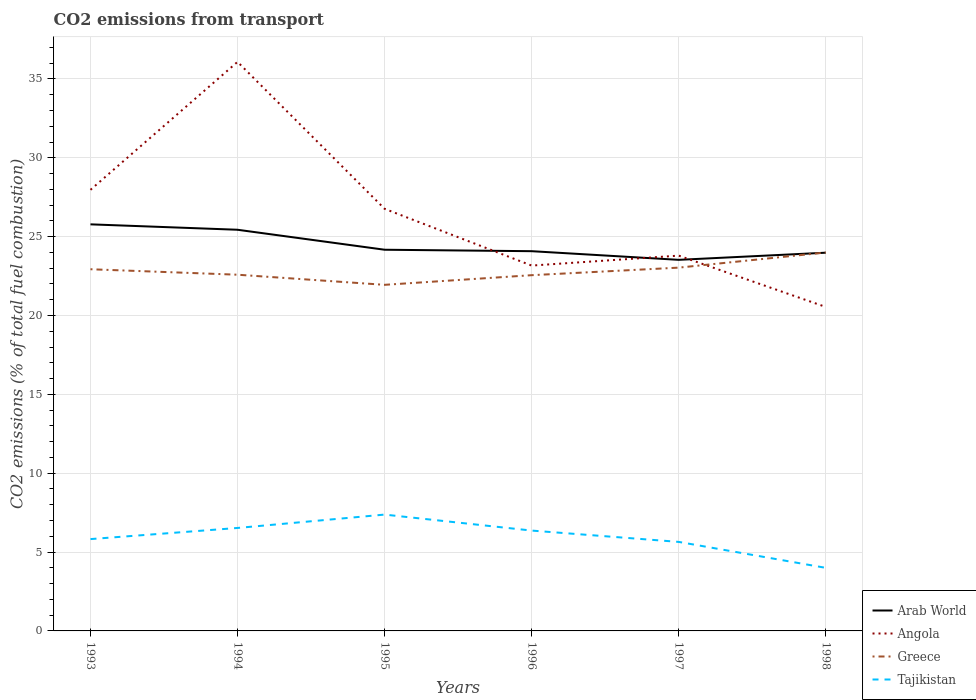How many different coloured lines are there?
Your answer should be compact. 4. Across all years, what is the maximum total CO2 emitted in Arab World?
Your response must be concise. 23.53. What is the total total CO2 emitted in Angola in the graph?
Make the answer very short. 3.6. What is the difference between the highest and the second highest total CO2 emitted in Greece?
Offer a very short reply. 2.05. Is the total CO2 emitted in Greece strictly greater than the total CO2 emitted in Angola over the years?
Your answer should be compact. No. How many years are there in the graph?
Your answer should be very brief. 6. Does the graph contain any zero values?
Your response must be concise. No. How many legend labels are there?
Provide a short and direct response. 4. What is the title of the graph?
Keep it short and to the point. CO2 emissions from transport. Does "St. Kitts and Nevis" appear as one of the legend labels in the graph?
Keep it short and to the point. No. What is the label or title of the Y-axis?
Your answer should be very brief. CO2 emissions (% of total fuel combustion). What is the CO2 emissions (% of total fuel combustion) in Arab World in 1993?
Your response must be concise. 25.78. What is the CO2 emissions (% of total fuel combustion) of Angola in 1993?
Your answer should be compact. 27.97. What is the CO2 emissions (% of total fuel combustion) of Greece in 1993?
Your response must be concise. 22.94. What is the CO2 emissions (% of total fuel combustion) in Tajikistan in 1993?
Your response must be concise. 5.82. What is the CO2 emissions (% of total fuel combustion) of Arab World in 1994?
Provide a short and direct response. 25.44. What is the CO2 emissions (% of total fuel combustion) in Angola in 1994?
Keep it short and to the point. 36.08. What is the CO2 emissions (% of total fuel combustion) in Greece in 1994?
Your answer should be very brief. 22.59. What is the CO2 emissions (% of total fuel combustion) in Tajikistan in 1994?
Offer a very short reply. 6.53. What is the CO2 emissions (% of total fuel combustion) of Arab World in 1995?
Offer a very short reply. 24.17. What is the CO2 emissions (% of total fuel combustion) of Angola in 1995?
Your response must be concise. 26.77. What is the CO2 emissions (% of total fuel combustion) in Greece in 1995?
Offer a very short reply. 21.95. What is the CO2 emissions (% of total fuel combustion) of Tajikistan in 1995?
Your answer should be very brief. 7.38. What is the CO2 emissions (% of total fuel combustion) of Arab World in 1996?
Provide a short and direct response. 24.08. What is the CO2 emissions (% of total fuel combustion) in Angola in 1996?
Offer a very short reply. 23.17. What is the CO2 emissions (% of total fuel combustion) in Greece in 1996?
Your answer should be compact. 22.56. What is the CO2 emissions (% of total fuel combustion) in Tajikistan in 1996?
Keep it short and to the point. 6.36. What is the CO2 emissions (% of total fuel combustion) of Arab World in 1997?
Your answer should be compact. 23.53. What is the CO2 emissions (% of total fuel combustion) of Angola in 1997?
Keep it short and to the point. 23.8. What is the CO2 emissions (% of total fuel combustion) in Greece in 1997?
Ensure brevity in your answer.  23.04. What is the CO2 emissions (% of total fuel combustion) of Tajikistan in 1997?
Provide a short and direct response. 5.65. What is the CO2 emissions (% of total fuel combustion) in Arab World in 1998?
Provide a short and direct response. 23.98. What is the CO2 emissions (% of total fuel combustion) in Angola in 1998?
Make the answer very short. 20.54. What is the CO2 emissions (% of total fuel combustion) in Greece in 1998?
Offer a very short reply. 24. What is the CO2 emissions (% of total fuel combustion) of Tajikistan in 1998?
Give a very brief answer. 4. Across all years, what is the maximum CO2 emissions (% of total fuel combustion) in Arab World?
Give a very brief answer. 25.78. Across all years, what is the maximum CO2 emissions (% of total fuel combustion) in Angola?
Make the answer very short. 36.08. Across all years, what is the maximum CO2 emissions (% of total fuel combustion) of Greece?
Keep it short and to the point. 24. Across all years, what is the maximum CO2 emissions (% of total fuel combustion) of Tajikistan?
Keep it short and to the point. 7.38. Across all years, what is the minimum CO2 emissions (% of total fuel combustion) of Arab World?
Offer a very short reply. 23.53. Across all years, what is the minimum CO2 emissions (% of total fuel combustion) of Angola?
Your answer should be compact. 20.54. Across all years, what is the minimum CO2 emissions (% of total fuel combustion) in Greece?
Your answer should be very brief. 21.95. Across all years, what is the minimum CO2 emissions (% of total fuel combustion) in Tajikistan?
Ensure brevity in your answer.  4. What is the total CO2 emissions (% of total fuel combustion) in Arab World in the graph?
Provide a succinct answer. 146.99. What is the total CO2 emissions (% of total fuel combustion) of Angola in the graph?
Offer a terse response. 158.34. What is the total CO2 emissions (% of total fuel combustion) in Greece in the graph?
Keep it short and to the point. 137.06. What is the total CO2 emissions (% of total fuel combustion) of Tajikistan in the graph?
Give a very brief answer. 35.74. What is the difference between the CO2 emissions (% of total fuel combustion) of Arab World in 1993 and that in 1994?
Your answer should be compact. 0.34. What is the difference between the CO2 emissions (% of total fuel combustion) in Angola in 1993 and that in 1994?
Your response must be concise. -8.11. What is the difference between the CO2 emissions (% of total fuel combustion) in Greece in 1993 and that in 1994?
Your answer should be compact. 0.35. What is the difference between the CO2 emissions (% of total fuel combustion) of Tajikistan in 1993 and that in 1994?
Your answer should be compact. -0.71. What is the difference between the CO2 emissions (% of total fuel combustion) of Arab World in 1993 and that in 1995?
Offer a very short reply. 1.61. What is the difference between the CO2 emissions (% of total fuel combustion) of Angola in 1993 and that in 1995?
Offer a very short reply. 1.2. What is the difference between the CO2 emissions (% of total fuel combustion) of Tajikistan in 1993 and that in 1995?
Your answer should be very brief. -1.55. What is the difference between the CO2 emissions (% of total fuel combustion) of Arab World in 1993 and that in 1996?
Offer a very short reply. 1.7. What is the difference between the CO2 emissions (% of total fuel combustion) in Angola in 1993 and that in 1996?
Offer a terse response. 4.8. What is the difference between the CO2 emissions (% of total fuel combustion) of Greece in 1993 and that in 1996?
Your answer should be very brief. 0.38. What is the difference between the CO2 emissions (% of total fuel combustion) in Tajikistan in 1993 and that in 1996?
Make the answer very short. -0.54. What is the difference between the CO2 emissions (% of total fuel combustion) in Arab World in 1993 and that in 1997?
Your answer should be compact. 2.25. What is the difference between the CO2 emissions (% of total fuel combustion) of Angola in 1993 and that in 1997?
Your answer should be very brief. 4.17. What is the difference between the CO2 emissions (% of total fuel combustion) in Greece in 1993 and that in 1997?
Provide a short and direct response. -0.1. What is the difference between the CO2 emissions (% of total fuel combustion) of Tajikistan in 1993 and that in 1997?
Make the answer very short. 0.18. What is the difference between the CO2 emissions (% of total fuel combustion) of Arab World in 1993 and that in 1998?
Provide a succinct answer. 1.8. What is the difference between the CO2 emissions (% of total fuel combustion) in Angola in 1993 and that in 1998?
Keep it short and to the point. 7.43. What is the difference between the CO2 emissions (% of total fuel combustion) in Greece in 1993 and that in 1998?
Your answer should be very brief. -1.06. What is the difference between the CO2 emissions (% of total fuel combustion) of Tajikistan in 1993 and that in 1998?
Provide a succinct answer. 1.82. What is the difference between the CO2 emissions (% of total fuel combustion) of Arab World in 1994 and that in 1995?
Your answer should be very brief. 1.27. What is the difference between the CO2 emissions (% of total fuel combustion) of Angola in 1994 and that in 1995?
Ensure brevity in your answer.  9.32. What is the difference between the CO2 emissions (% of total fuel combustion) in Greece in 1994 and that in 1995?
Keep it short and to the point. 0.64. What is the difference between the CO2 emissions (% of total fuel combustion) in Tajikistan in 1994 and that in 1995?
Keep it short and to the point. -0.85. What is the difference between the CO2 emissions (% of total fuel combustion) in Arab World in 1994 and that in 1996?
Offer a very short reply. 1.36. What is the difference between the CO2 emissions (% of total fuel combustion) of Angola in 1994 and that in 1996?
Keep it short and to the point. 12.92. What is the difference between the CO2 emissions (% of total fuel combustion) of Greece in 1994 and that in 1996?
Make the answer very short. 0.03. What is the difference between the CO2 emissions (% of total fuel combustion) in Tajikistan in 1994 and that in 1996?
Provide a short and direct response. 0.17. What is the difference between the CO2 emissions (% of total fuel combustion) of Arab World in 1994 and that in 1997?
Your response must be concise. 1.91. What is the difference between the CO2 emissions (% of total fuel combustion) in Angola in 1994 and that in 1997?
Offer a terse response. 12.29. What is the difference between the CO2 emissions (% of total fuel combustion) in Greece in 1994 and that in 1997?
Provide a succinct answer. -0.45. What is the difference between the CO2 emissions (% of total fuel combustion) of Tajikistan in 1994 and that in 1997?
Your response must be concise. 0.88. What is the difference between the CO2 emissions (% of total fuel combustion) of Arab World in 1994 and that in 1998?
Offer a very short reply. 1.46. What is the difference between the CO2 emissions (% of total fuel combustion) of Angola in 1994 and that in 1998?
Make the answer very short. 15.54. What is the difference between the CO2 emissions (% of total fuel combustion) in Greece in 1994 and that in 1998?
Give a very brief answer. -1.41. What is the difference between the CO2 emissions (% of total fuel combustion) in Tajikistan in 1994 and that in 1998?
Your response must be concise. 2.53. What is the difference between the CO2 emissions (% of total fuel combustion) in Arab World in 1995 and that in 1996?
Offer a terse response. 0.09. What is the difference between the CO2 emissions (% of total fuel combustion) of Angola in 1995 and that in 1996?
Offer a terse response. 3.6. What is the difference between the CO2 emissions (% of total fuel combustion) in Greece in 1995 and that in 1996?
Your answer should be compact. -0.61. What is the difference between the CO2 emissions (% of total fuel combustion) in Tajikistan in 1995 and that in 1996?
Your answer should be compact. 1.01. What is the difference between the CO2 emissions (% of total fuel combustion) in Arab World in 1995 and that in 1997?
Give a very brief answer. 0.64. What is the difference between the CO2 emissions (% of total fuel combustion) in Angola in 1995 and that in 1997?
Your answer should be very brief. 2.97. What is the difference between the CO2 emissions (% of total fuel combustion) in Greece in 1995 and that in 1997?
Your answer should be compact. -1.09. What is the difference between the CO2 emissions (% of total fuel combustion) of Tajikistan in 1995 and that in 1997?
Make the answer very short. 1.73. What is the difference between the CO2 emissions (% of total fuel combustion) of Arab World in 1995 and that in 1998?
Your answer should be very brief. 0.19. What is the difference between the CO2 emissions (% of total fuel combustion) of Angola in 1995 and that in 1998?
Provide a succinct answer. 6.22. What is the difference between the CO2 emissions (% of total fuel combustion) in Greece in 1995 and that in 1998?
Ensure brevity in your answer.  -2.05. What is the difference between the CO2 emissions (% of total fuel combustion) in Tajikistan in 1995 and that in 1998?
Make the answer very short. 3.38. What is the difference between the CO2 emissions (% of total fuel combustion) in Arab World in 1996 and that in 1997?
Give a very brief answer. 0.55. What is the difference between the CO2 emissions (% of total fuel combustion) in Angola in 1996 and that in 1997?
Offer a terse response. -0.63. What is the difference between the CO2 emissions (% of total fuel combustion) in Greece in 1996 and that in 1997?
Offer a very short reply. -0.48. What is the difference between the CO2 emissions (% of total fuel combustion) of Tajikistan in 1996 and that in 1997?
Provide a short and direct response. 0.72. What is the difference between the CO2 emissions (% of total fuel combustion) of Arab World in 1996 and that in 1998?
Provide a succinct answer. 0.1. What is the difference between the CO2 emissions (% of total fuel combustion) in Angola in 1996 and that in 1998?
Your answer should be compact. 2.62. What is the difference between the CO2 emissions (% of total fuel combustion) in Greece in 1996 and that in 1998?
Your response must be concise. -1.44. What is the difference between the CO2 emissions (% of total fuel combustion) of Tajikistan in 1996 and that in 1998?
Provide a succinct answer. 2.36. What is the difference between the CO2 emissions (% of total fuel combustion) in Arab World in 1997 and that in 1998?
Offer a terse response. -0.45. What is the difference between the CO2 emissions (% of total fuel combustion) in Angola in 1997 and that in 1998?
Ensure brevity in your answer.  3.25. What is the difference between the CO2 emissions (% of total fuel combustion) in Greece in 1997 and that in 1998?
Your answer should be compact. -0.96. What is the difference between the CO2 emissions (% of total fuel combustion) of Tajikistan in 1997 and that in 1998?
Ensure brevity in your answer.  1.65. What is the difference between the CO2 emissions (% of total fuel combustion) in Arab World in 1993 and the CO2 emissions (% of total fuel combustion) in Angola in 1994?
Your answer should be compact. -10.3. What is the difference between the CO2 emissions (% of total fuel combustion) of Arab World in 1993 and the CO2 emissions (% of total fuel combustion) of Greece in 1994?
Offer a very short reply. 3.19. What is the difference between the CO2 emissions (% of total fuel combustion) in Arab World in 1993 and the CO2 emissions (% of total fuel combustion) in Tajikistan in 1994?
Provide a succinct answer. 19.25. What is the difference between the CO2 emissions (% of total fuel combustion) of Angola in 1993 and the CO2 emissions (% of total fuel combustion) of Greece in 1994?
Make the answer very short. 5.38. What is the difference between the CO2 emissions (% of total fuel combustion) in Angola in 1993 and the CO2 emissions (% of total fuel combustion) in Tajikistan in 1994?
Offer a terse response. 21.44. What is the difference between the CO2 emissions (% of total fuel combustion) in Greece in 1993 and the CO2 emissions (% of total fuel combustion) in Tajikistan in 1994?
Your response must be concise. 16.41. What is the difference between the CO2 emissions (% of total fuel combustion) in Arab World in 1993 and the CO2 emissions (% of total fuel combustion) in Angola in 1995?
Your response must be concise. -0.99. What is the difference between the CO2 emissions (% of total fuel combustion) in Arab World in 1993 and the CO2 emissions (% of total fuel combustion) in Greece in 1995?
Provide a short and direct response. 3.84. What is the difference between the CO2 emissions (% of total fuel combustion) of Arab World in 1993 and the CO2 emissions (% of total fuel combustion) of Tajikistan in 1995?
Give a very brief answer. 18.41. What is the difference between the CO2 emissions (% of total fuel combustion) in Angola in 1993 and the CO2 emissions (% of total fuel combustion) in Greece in 1995?
Offer a very short reply. 6.03. What is the difference between the CO2 emissions (% of total fuel combustion) in Angola in 1993 and the CO2 emissions (% of total fuel combustion) in Tajikistan in 1995?
Provide a succinct answer. 20.59. What is the difference between the CO2 emissions (% of total fuel combustion) of Greece in 1993 and the CO2 emissions (% of total fuel combustion) of Tajikistan in 1995?
Make the answer very short. 15.56. What is the difference between the CO2 emissions (% of total fuel combustion) of Arab World in 1993 and the CO2 emissions (% of total fuel combustion) of Angola in 1996?
Provide a short and direct response. 2.61. What is the difference between the CO2 emissions (% of total fuel combustion) of Arab World in 1993 and the CO2 emissions (% of total fuel combustion) of Greece in 1996?
Your answer should be compact. 3.22. What is the difference between the CO2 emissions (% of total fuel combustion) of Arab World in 1993 and the CO2 emissions (% of total fuel combustion) of Tajikistan in 1996?
Your response must be concise. 19.42. What is the difference between the CO2 emissions (% of total fuel combustion) in Angola in 1993 and the CO2 emissions (% of total fuel combustion) in Greece in 1996?
Your answer should be compact. 5.41. What is the difference between the CO2 emissions (% of total fuel combustion) in Angola in 1993 and the CO2 emissions (% of total fuel combustion) in Tajikistan in 1996?
Your response must be concise. 21.61. What is the difference between the CO2 emissions (% of total fuel combustion) of Greece in 1993 and the CO2 emissions (% of total fuel combustion) of Tajikistan in 1996?
Provide a succinct answer. 16.57. What is the difference between the CO2 emissions (% of total fuel combustion) in Arab World in 1993 and the CO2 emissions (% of total fuel combustion) in Angola in 1997?
Provide a short and direct response. 1.98. What is the difference between the CO2 emissions (% of total fuel combustion) in Arab World in 1993 and the CO2 emissions (% of total fuel combustion) in Greece in 1997?
Your response must be concise. 2.75. What is the difference between the CO2 emissions (% of total fuel combustion) of Arab World in 1993 and the CO2 emissions (% of total fuel combustion) of Tajikistan in 1997?
Your response must be concise. 20.14. What is the difference between the CO2 emissions (% of total fuel combustion) of Angola in 1993 and the CO2 emissions (% of total fuel combustion) of Greece in 1997?
Ensure brevity in your answer.  4.94. What is the difference between the CO2 emissions (% of total fuel combustion) of Angola in 1993 and the CO2 emissions (% of total fuel combustion) of Tajikistan in 1997?
Offer a very short reply. 22.33. What is the difference between the CO2 emissions (% of total fuel combustion) of Greece in 1993 and the CO2 emissions (% of total fuel combustion) of Tajikistan in 1997?
Your answer should be very brief. 17.29. What is the difference between the CO2 emissions (% of total fuel combustion) of Arab World in 1993 and the CO2 emissions (% of total fuel combustion) of Angola in 1998?
Your answer should be very brief. 5.24. What is the difference between the CO2 emissions (% of total fuel combustion) of Arab World in 1993 and the CO2 emissions (% of total fuel combustion) of Greece in 1998?
Keep it short and to the point. 1.78. What is the difference between the CO2 emissions (% of total fuel combustion) of Arab World in 1993 and the CO2 emissions (% of total fuel combustion) of Tajikistan in 1998?
Give a very brief answer. 21.78. What is the difference between the CO2 emissions (% of total fuel combustion) of Angola in 1993 and the CO2 emissions (% of total fuel combustion) of Greece in 1998?
Provide a succinct answer. 3.97. What is the difference between the CO2 emissions (% of total fuel combustion) of Angola in 1993 and the CO2 emissions (% of total fuel combustion) of Tajikistan in 1998?
Keep it short and to the point. 23.97. What is the difference between the CO2 emissions (% of total fuel combustion) in Greece in 1993 and the CO2 emissions (% of total fuel combustion) in Tajikistan in 1998?
Give a very brief answer. 18.94. What is the difference between the CO2 emissions (% of total fuel combustion) in Arab World in 1994 and the CO2 emissions (% of total fuel combustion) in Angola in 1995?
Offer a terse response. -1.33. What is the difference between the CO2 emissions (% of total fuel combustion) in Arab World in 1994 and the CO2 emissions (% of total fuel combustion) in Greece in 1995?
Provide a succinct answer. 3.49. What is the difference between the CO2 emissions (% of total fuel combustion) of Arab World in 1994 and the CO2 emissions (% of total fuel combustion) of Tajikistan in 1995?
Offer a terse response. 18.06. What is the difference between the CO2 emissions (% of total fuel combustion) in Angola in 1994 and the CO2 emissions (% of total fuel combustion) in Greece in 1995?
Keep it short and to the point. 14.14. What is the difference between the CO2 emissions (% of total fuel combustion) in Angola in 1994 and the CO2 emissions (% of total fuel combustion) in Tajikistan in 1995?
Give a very brief answer. 28.71. What is the difference between the CO2 emissions (% of total fuel combustion) in Greece in 1994 and the CO2 emissions (% of total fuel combustion) in Tajikistan in 1995?
Provide a succinct answer. 15.21. What is the difference between the CO2 emissions (% of total fuel combustion) of Arab World in 1994 and the CO2 emissions (% of total fuel combustion) of Angola in 1996?
Provide a short and direct response. 2.27. What is the difference between the CO2 emissions (% of total fuel combustion) of Arab World in 1994 and the CO2 emissions (% of total fuel combustion) of Greece in 1996?
Provide a succinct answer. 2.88. What is the difference between the CO2 emissions (% of total fuel combustion) in Arab World in 1994 and the CO2 emissions (% of total fuel combustion) in Tajikistan in 1996?
Provide a short and direct response. 19.08. What is the difference between the CO2 emissions (% of total fuel combustion) in Angola in 1994 and the CO2 emissions (% of total fuel combustion) in Greece in 1996?
Your answer should be very brief. 13.53. What is the difference between the CO2 emissions (% of total fuel combustion) in Angola in 1994 and the CO2 emissions (% of total fuel combustion) in Tajikistan in 1996?
Offer a terse response. 29.72. What is the difference between the CO2 emissions (% of total fuel combustion) of Greece in 1994 and the CO2 emissions (% of total fuel combustion) of Tajikistan in 1996?
Offer a terse response. 16.22. What is the difference between the CO2 emissions (% of total fuel combustion) in Arab World in 1994 and the CO2 emissions (% of total fuel combustion) in Angola in 1997?
Provide a succinct answer. 1.64. What is the difference between the CO2 emissions (% of total fuel combustion) in Arab World in 1994 and the CO2 emissions (% of total fuel combustion) in Greece in 1997?
Keep it short and to the point. 2.4. What is the difference between the CO2 emissions (% of total fuel combustion) in Arab World in 1994 and the CO2 emissions (% of total fuel combustion) in Tajikistan in 1997?
Offer a very short reply. 19.79. What is the difference between the CO2 emissions (% of total fuel combustion) of Angola in 1994 and the CO2 emissions (% of total fuel combustion) of Greece in 1997?
Provide a succinct answer. 13.05. What is the difference between the CO2 emissions (% of total fuel combustion) in Angola in 1994 and the CO2 emissions (% of total fuel combustion) in Tajikistan in 1997?
Your answer should be compact. 30.44. What is the difference between the CO2 emissions (% of total fuel combustion) in Greece in 1994 and the CO2 emissions (% of total fuel combustion) in Tajikistan in 1997?
Your answer should be compact. 16.94. What is the difference between the CO2 emissions (% of total fuel combustion) in Arab World in 1994 and the CO2 emissions (% of total fuel combustion) in Angola in 1998?
Keep it short and to the point. 4.89. What is the difference between the CO2 emissions (% of total fuel combustion) of Arab World in 1994 and the CO2 emissions (% of total fuel combustion) of Greece in 1998?
Give a very brief answer. 1.44. What is the difference between the CO2 emissions (% of total fuel combustion) in Arab World in 1994 and the CO2 emissions (% of total fuel combustion) in Tajikistan in 1998?
Offer a terse response. 21.44. What is the difference between the CO2 emissions (% of total fuel combustion) of Angola in 1994 and the CO2 emissions (% of total fuel combustion) of Greece in 1998?
Your answer should be very brief. 12.09. What is the difference between the CO2 emissions (% of total fuel combustion) of Angola in 1994 and the CO2 emissions (% of total fuel combustion) of Tajikistan in 1998?
Provide a succinct answer. 32.08. What is the difference between the CO2 emissions (% of total fuel combustion) of Greece in 1994 and the CO2 emissions (% of total fuel combustion) of Tajikistan in 1998?
Your answer should be very brief. 18.59. What is the difference between the CO2 emissions (% of total fuel combustion) of Arab World in 1995 and the CO2 emissions (% of total fuel combustion) of Angola in 1996?
Keep it short and to the point. 1. What is the difference between the CO2 emissions (% of total fuel combustion) in Arab World in 1995 and the CO2 emissions (% of total fuel combustion) in Greece in 1996?
Your answer should be compact. 1.61. What is the difference between the CO2 emissions (% of total fuel combustion) in Arab World in 1995 and the CO2 emissions (% of total fuel combustion) in Tajikistan in 1996?
Offer a terse response. 17.81. What is the difference between the CO2 emissions (% of total fuel combustion) of Angola in 1995 and the CO2 emissions (% of total fuel combustion) of Greece in 1996?
Give a very brief answer. 4.21. What is the difference between the CO2 emissions (% of total fuel combustion) of Angola in 1995 and the CO2 emissions (% of total fuel combustion) of Tajikistan in 1996?
Keep it short and to the point. 20.4. What is the difference between the CO2 emissions (% of total fuel combustion) of Greece in 1995 and the CO2 emissions (% of total fuel combustion) of Tajikistan in 1996?
Your response must be concise. 15.58. What is the difference between the CO2 emissions (% of total fuel combustion) in Arab World in 1995 and the CO2 emissions (% of total fuel combustion) in Angola in 1997?
Ensure brevity in your answer.  0.37. What is the difference between the CO2 emissions (% of total fuel combustion) of Arab World in 1995 and the CO2 emissions (% of total fuel combustion) of Greece in 1997?
Your answer should be compact. 1.14. What is the difference between the CO2 emissions (% of total fuel combustion) of Arab World in 1995 and the CO2 emissions (% of total fuel combustion) of Tajikistan in 1997?
Make the answer very short. 18.53. What is the difference between the CO2 emissions (% of total fuel combustion) of Angola in 1995 and the CO2 emissions (% of total fuel combustion) of Greece in 1997?
Provide a succinct answer. 3.73. What is the difference between the CO2 emissions (% of total fuel combustion) in Angola in 1995 and the CO2 emissions (% of total fuel combustion) in Tajikistan in 1997?
Provide a short and direct response. 21.12. What is the difference between the CO2 emissions (% of total fuel combustion) in Greece in 1995 and the CO2 emissions (% of total fuel combustion) in Tajikistan in 1997?
Offer a terse response. 16.3. What is the difference between the CO2 emissions (% of total fuel combustion) in Arab World in 1995 and the CO2 emissions (% of total fuel combustion) in Angola in 1998?
Your response must be concise. 3.63. What is the difference between the CO2 emissions (% of total fuel combustion) of Arab World in 1995 and the CO2 emissions (% of total fuel combustion) of Greece in 1998?
Your answer should be compact. 0.17. What is the difference between the CO2 emissions (% of total fuel combustion) in Arab World in 1995 and the CO2 emissions (% of total fuel combustion) in Tajikistan in 1998?
Offer a very short reply. 20.17. What is the difference between the CO2 emissions (% of total fuel combustion) of Angola in 1995 and the CO2 emissions (% of total fuel combustion) of Greece in 1998?
Provide a short and direct response. 2.77. What is the difference between the CO2 emissions (% of total fuel combustion) of Angola in 1995 and the CO2 emissions (% of total fuel combustion) of Tajikistan in 1998?
Offer a terse response. 22.77. What is the difference between the CO2 emissions (% of total fuel combustion) of Greece in 1995 and the CO2 emissions (% of total fuel combustion) of Tajikistan in 1998?
Give a very brief answer. 17.95. What is the difference between the CO2 emissions (% of total fuel combustion) of Arab World in 1996 and the CO2 emissions (% of total fuel combustion) of Angola in 1997?
Give a very brief answer. 0.28. What is the difference between the CO2 emissions (% of total fuel combustion) of Arab World in 1996 and the CO2 emissions (% of total fuel combustion) of Greece in 1997?
Give a very brief answer. 1.04. What is the difference between the CO2 emissions (% of total fuel combustion) in Arab World in 1996 and the CO2 emissions (% of total fuel combustion) in Tajikistan in 1997?
Offer a terse response. 18.43. What is the difference between the CO2 emissions (% of total fuel combustion) in Angola in 1996 and the CO2 emissions (% of total fuel combustion) in Greece in 1997?
Provide a succinct answer. 0.13. What is the difference between the CO2 emissions (% of total fuel combustion) in Angola in 1996 and the CO2 emissions (% of total fuel combustion) in Tajikistan in 1997?
Your response must be concise. 17.52. What is the difference between the CO2 emissions (% of total fuel combustion) in Greece in 1996 and the CO2 emissions (% of total fuel combustion) in Tajikistan in 1997?
Offer a very short reply. 16.91. What is the difference between the CO2 emissions (% of total fuel combustion) in Arab World in 1996 and the CO2 emissions (% of total fuel combustion) in Angola in 1998?
Give a very brief answer. 3.54. What is the difference between the CO2 emissions (% of total fuel combustion) of Arab World in 1996 and the CO2 emissions (% of total fuel combustion) of Greece in 1998?
Offer a terse response. 0.08. What is the difference between the CO2 emissions (% of total fuel combustion) in Arab World in 1996 and the CO2 emissions (% of total fuel combustion) in Tajikistan in 1998?
Ensure brevity in your answer.  20.08. What is the difference between the CO2 emissions (% of total fuel combustion) in Angola in 1996 and the CO2 emissions (% of total fuel combustion) in Greece in 1998?
Offer a terse response. -0.83. What is the difference between the CO2 emissions (% of total fuel combustion) of Angola in 1996 and the CO2 emissions (% of total fuel combustion) of Tajikistan in 1998?
Provide a succinct answer. 19.17. What is the difference between the CO2 emissions (% of total fuel combustion) in Greece in 1996 and the CO2 emissions (% of total fuel combustion) in Tajikistan in 1998?
Your answer should be compact. 18.56. What is the difference between the CO2 emissions (% of total fuel combustion) of Arab World in 1997 and the CO2 emissions (% of total fuel combustion) of Angola in 1998?
Offer a very short reply. 2.99. What is the difference between the CO2 emissions (% of total fuel combustion) of Arab World in 1997 and the CO2 emissions (% of total fuel combustion) of Greece in 1998?
Offer a very short reply. -0.47. What is the difference between the CO2 emissions (% of total fuel combustion) of Arab World in 1997 and the CO2 emissions (% of total fuel combustion) of Tajikistan in 1998?
Provide a short and direct response. 19.53. What is the difference between the CO2 emissions (% of total fuel combustion) in Angola in 1997 and the CO2 emissions (% of total fuel combustion) in Greece in 1998?
Ensure brevity in your answer.  -0.2. What is the difference between the CO2 emissions (% of total fuel combustion) of Angola in 1997 and the CO2 emissions (% of total fuel combustion) of Tajikistan in 1998?
Your response must be concise. 19.8. What is the difference between the CO2 emissions (% of total fuel combustion) of Greece in 1997 and the CO2 emissions (% of total fuel combustion) of Tajikistan in 1998?
Offer a very short reply. 19.04. What is the average CO2 emissions (% of total fuel combustion) of Arab World per year?
Your answer should be very brief. 24.5. What is the average CO2 emissions (% of total fuel combustion) in Angola per year?
Make the answer very short. 26.39. What is the average CO2 emissions (% of total fuel combustion) of Greece per year?
Offer a very short reply. 22.84. What is the average CO2 emissions (% of total fuel combustion) in Tajikistan per year?
Your response must be concise. 5.96. In the year 1993, what is the difference between the CO2 emissions (% of total fuel combustion) in Arab World and CO2 emissions (% of total fuel combustion) in Angola?
Offer a very short reply. -2.19. In the year 1993, what is the difference between the CO2 emissions (% of total fuel combustion) of Arab World and CO2 emissions (% of total fuel combustion) of Greece?
Your answer should be very brief. 2.85. In the year 1993, what is the difference between the CO2 emissions (% of total fuel combustion) of Arab World and CO2 emissions (% of total fuel combustion) of Tajikistan?
Give a very brief answer. 19.96. In the year 1993, what is the difference between the CO2 emissions (% of total fuel combustion) of Angola and CO2 emissions (% of total fuel combustion) of Greece?
Provide a short and direct response. 5.04. In the year 1993, what is the difference between the CO2 emissions (% of total fuel combustion) in Angola and CO2 emissions (% of total fuel combustion) in Tajikistan?
Provide a short and direct response. 22.15. In the year 1993, what is the difference between the CO2 emissions (% of total fuel combustion) in Greece and CO2 emissions (% of total fuel combustion) in Tajikistan?
Offer a terse response. 17.11. In the year 1994, what is the difference between the CO2 emissions (% of total fuel combustion) of Arab World and CO2 emissions (% of total fuel combustion) of Angola?
Ensure brevity in your answer.  -10.65. In the year 1994, what is the difference between the CO2 emissions (% of total fuel combustion) of Arab World and CO2 emissions (% of total fuel combustion) of Greece?
Offer a terse response. 2.85. In the year 1994, what is the difference between the CO2 emissions (% of total fuel combustion) in Arab World and CO2 emissions (% of total fuel combustion) in Tajikistan?
Give a very brief answer. 18.91. In the year 1994, what is the difference between the CO2 emissions (% of total fuel combustion) of Angola and CO2 emissions (% of total fuel combustion) of Greece?
Keep it short and to the point. 13.5. In the year 1994, what is the difference between the CO2 emissions (% of total fuel combustion) in Angola and CO2 emissions (% of total fuel combustion) in Tajikistan?
Your answer should be compact. 29.56. In the year 1994, what is the difference between the CO2 emissions (% of total fuel combustion) of Greece and CO2 emissions (% of total fuel combustion) of Tajikistan?
Your response must be concise. 16.06. In the year 1995, what is the difference between the CO2 emissions (% of total fuel combustion) in Arab World and CO2 emissions (% of total fuel combustion) in Angola?
Keep it short and to the point. -2.6. In the year 1995, what is the difference between the CO2 emissions (% of total fuel combustion) of Arab World and CO2 emissions (% of total fuel combustion) of Greece?
Give a very brief answer. 2.23. In the year 1995, what is the difference between the CO2 emissions (% of total fuel combustion) of Arab World and CO2 emissions (% of total fuel combustion) of Tajikistan?
Offer a very short reply. 16.8. In the year 1995, what is the difference between the CO2 emissions (% of total fuel combustion) of Angola and CO2 emissions (% of total fuel combustion) of Greece?
Offer a very short reply. 4.82. In the year 1995, what is the difference between the CO2 emissions (% of total fuel combustion) of Angola and CO2 emissions (% of total fuel combustion) of Tajikistan?
Keep it short and to the point. 19.39. In the year 1995, what is the difference between the CO2 emissions (% of total fuel combustion) of Greece and CO2 emissions (% of total fuel combustion) of Tajikistan?
Offer a very short reply. 14.57. In the year 1996, what is the difference between the CO2 emissions (% of total fuel combustion) in Arab World and CO2 emissions (% of total fuel combustion) in Angola?
Give a very brief answer. 0.91. In the year 1996, what is the difference between the CO2 emissions (% of total fuel combustion) in Arab World and CO2 emissions (% of total fuel combustion) in Greece?
Provide a short and direct response. 1.52. In the year 1996, what is the difference between the CO2 emissions (% of total fuel combustion) of Arab World and CO2 emissions (% of total fuel combustion) of Tajikistan?
Ensure brevity in your answer.  17.72. In the year 1996, what is the difference between the CO2 emissions (% of total fuel combustion) in Angola and CO2 emissions (% of total fuel combustion) in Greece?
Keep it short and to the point. 0.61. In the year 1996, what is the difference between the CO2 emissions (% of total fuel combustion) of Angola and CO2 emissions (% of total fuel combustion) of Tajikistan?
Ensure brevity in your answer.  16.8. In the year 1996, what is the difference between the CO2 emissions (% of total fuel combustion) of Greece and CO2 emissions (% of total fuel combustion) of Tajikistan?
Provide a succinct answer. 16.19. In the year 1997, what is the difference between the CO2 emissions (% of total fuel combustion) of Arab World and CO2 emissions (% of total fuel combustion) of Angola?
Offer a terse response. -0.27. In the year 1997, what is the difference between the CO2 emissions (% of total fuel combustion) in Arab World and CO2 emissions (% of total fuel combustion) in Greece?
Offer a terse response. 0.49. In the year 1997, what is the difference between the CO2 emissions (% of total fuel combustion) of Arab World and CO2 emissions (% of total fuel combustion) of Tajikistan?
Your answer should be very brief. 17.89. In the year 1997, what is the difference between the CO2 emissions (% of total fuel combustion) in Angola and CO2 emissions (% of total fuel combustion) in Greece?
Keep it short and to the point. 0.76. In the year 1997, what is the difference between the CO2 emissions (% of total fuel combustion) of Angola and CO2 emissions (% of total fuel combustion) of Tajikistan?
Ensure brevity in your answer.  18.15. In the year 1997, what is the difference between the CO2 emissions (% of total fuel combustion) of Greece and CO2 emissions (% of total fuel combustion) of Tajikistan?
Offer a terse response. 17.39. In the year 1998, what is the difference between the CO2 emissions (% of total fuel combustion) in Arab World and CO2 emissions (% of total fuel combustion) in Angola?
Your answer should be compact. 3.44. In the year 1998, what is the difference between the CO2 emissions (% of total fuel combustion) of Arab World and CO2 emissions (% of total fuel combustion) of Greece?
Provide a short and direct response. -0.01. In the year 1998, what is the difference between the CO2 emissions (% of total fuel combustion) in Arab World and CO2 emissions (% of total fuel combustion) in Tajikistan?
Your answer should be very brief. 19.98. In the year 1998, what is the difference between the CO2 emissions (% of total fuel combustion) of Angola and CO2 emissions (% of total fuel combustion) of Greece?
Offer a terse response. -3.45. In the year 1998, what is the difference between the CO2 emissions (% of total fuel combustion) in Angola and CO2 emissions (% of total fuel combustion) in Tajikistan?
Provide a short and direct response. 16.54. In the year 1998, what is the difference between the CO2 emissions (% of total fuel combustion) in Greece and CO2 emissions (% of total fuel combustion) in Tajikistan?
Offer a terse response. 20. What is the ratio of the CO2 emissions (% of total fuel combustion) of Arab World in 1993 to that in 1994?
Your answer should be compact. 1.01. What is the ratio of the CO2 emissions (% of total fuel combustion) of Angola in 1993 to that in 1994?
Make the answer very short. 0.78. What is the ratio of the CO2 emissions (% of total fuel combustion) in Greece in 1993 to that in 1994?
Your response must be concise. 1.02. What is the ratio of the CO2 emissions (% of total fuel combustion) of Tajikistan in 1993 to that in 1994?
Your answer should be very brief. 0.89. What is the ratio of the CO2 emissions (% of total fuel combustion) in Arab World in 1993 to that in 1995?
Provide a short and direct response. 1.07. What is the ratio of the CO2 emissions (% of total fuel combustion) of Angola in 1993 to that in 1995?
Offer a very short reply. 1.04. What is the ratio of the CO2 emissions (% of total fuel combustion) of Greece in 1993 to that in 1995?
Make the answer very short. 1.04. What is the ratio of the CO2 emissions (% of total fuel combustion) of Tajikistan in 1993 to that in 1995?
Your response must be concise. 0.79. What is the ratio of the CO2 emissions (% of total fuel combustion) in Arab World in 1993 to that in 1996?
Keep it short and to the point. 1.07. What is the ratio of the CO2 emissions (% of total fuel combustion) in Angola in 1993 to that in 1996?
Keep it short and to the point. 1.21. What is the ratio of the CO2 emissions (% of total fuel combustion) of Greece in 1993 to that in 1996?
Your answer should be compact. 1.02. What is the ratio of the CO2 emissions (% of total fuel combustion) of Tajikistan in 1993 to that in 1996?
Offer a very short reply. 0.92. What is the ratio of the CO2 emissions (% of total fuel combustion) in Arab World in 1993 to that in 1997?
Your response must be concise. 1.1. What is the ratio of the CO2 emissions (% of total fuel combustion) in Angola in 1993 to that in 1997?
Your response must be concise. 1.18. What is the ratio of the CO2 emissions (% of total fuel combustion) of Tajikistan in 1993 to that in 1997?
Offer a terse response. 1.03. What is the ratio of the CO2 emissions (% of total fuel combustion) in Arab World in 1993 to that in 1998?
Provide a succinct answer. 1.07. What is the ratio of the CO2 emissions (% of total fuel combustion) in Angola in 1993 to that in 1998?
Ensure brevity in your answer.  1.36. What is the ratio of the CO2 emissions (% of total fuel combustion) of Greece in 1993 to that in 1998?
Offer a very short reply. 0.96. What is the ratio of the CO2 emissions (% of total fuel combustion) in Tajikistan in 1993 to that in 1998?
Offer a terse response. 1.46. What is the ratio of the CO2 emissions (% of total fuel combustion) of Arab World in 1994 to that in 1995?
Keep it short and to the point. 1.05. What is the ratio of the CO2 emissions (% of total fuel combustion) of Angola in 1994 to that in 1995?
Offer a very short reply. 1.35. What is the ratio of the CO2 emissions (% of total fuel combustion) in Greece in 1994 to that in 1995?
Offer a terse response. 1.03. What is the ratio of the CO2 emissions (% of total fuel combustion) in Tajikistan in 1994 to that in 1995?
Your response must be concise. 0.89. What is the ratio of the CO2 emissions (% of total fuel combustion) of Arab World in 1994 to that in 1996?
Ensure brevity in your answer.  1.06. What is the ratio of the CO2 emissions (% of total fuel combustion) of Angola in 1994 to that in 1996?
Offer a very short reply. 1.56. What is the ratio of the CO2 emissions (% of total fuel combustion) in Greece in 1994 to that in 1996?
Provide a succinct answer. 1. What is the ratio of the CO2 emissions (% of total fuel combustion) of Arab World in 1994 to that in 1997?
Offer a very short reply. 1.08. What is the ratio of the CO2 emissions (% of total fuel combustion) of Angola in 1994 to that in 1997?
Your answer should be compact. 1.52. What is the ratio of the CO2 emissions (% of total fuel combustion) in Greece in 1994 to that in 1997?
Provide a short and direct response. 0.98. What is the ratio of the CO2 emissions (% of total fuel combustion) of Tajikistan in 1994 to that in 1997?
Provide a succinct answer. 1.16. What is the ratio of the CO2 emissions (% of total fuel combustion) of Arab World in 1994 to that in 1998?
Provide a succinct answer. 1.06. What is the ratio of the CO2 emissions (% of total fuel combustion) in Angola in 1994 to that in 1998?
Ensure brevity in your answer.  1.76. What is the ratio of the CO2 emissions (% of total fuel combustion) of Greece in 1994 to that in 1998?
Offer a very short reply. 0.94. What is the ratio of the CO2 emissions (% of total fuel combustion) in Tajikistan in 1994 to that in 1998?
Your answer should be very brief. 1.63. What is the ratio of the CO2 emissions (% of total fuel combustion) of Angola in 1995 to that in 1996?
Your answer should be compact. 1.16. What is the ratio of the CO2 emissions (% of total fuel combustion) in Greece in 1995 to that in 1996?
Your response must be concise. 0.97. What is the ratio of the CO2 emissions (% of total fuel combustion) in Tajikistan in 1995 to that in 1996?
Keep it short and to the point. 1.16. What is the ratio of the CO2 emissions (% of total fuel combustion) in Arab World in 1995 to that in 1997?
Provide a succinct answer. 1.03. What is the ratio of the CO2 emissions (% of total fuel combustion) of Angola in 1995 to that in 1997?
Your answer should be very brief. 1.12. What is the ratio of the CO2 emissions (% of total fuel combustion) in Greece in 1995 to that in 1997?
Provide a succinct answer. 0.95. What is the ratio of the CO2 emissions (% of total fuel combustion) in Tajikistan in 1995 to that in 1997?
Your answer should be very brief. 1.31. What is the ratio of the CO2 emissions (% of total fuel combustion) in Arab World in 1995 to that in 1998?
Provide a succinct answer. 1.01. What is the ratio of the CO2 emissions (% of total fuel combustion) of Angola in 1995 to that in 1998?
Your response must be concise. 1.3. What is the ratio of the CO2 emissions (% of total fuel combustion) of Greece in 1995 to that in 1998?
Keep it short and to the point. 0.91. What is the ratio of the CO2 emissions (% of total fuel combustion) in Tajikistan in 1995 to that in 1998?
Provide a succinct answer. 1.84. What is the ratio of the CO2 emissions (% of total fuel combustion) in Arab World in 1996 to that in 1997?
Provide a short and direct response. 1.02. What is the ratio of the CO2 emissions (% of total fuel combustion) in Angola in 1996 to that in 1997?
Offer a very short reply. 0.97. What is the ratio of the CO2 emissions (% of total fuel combustion) in Greece in 1996 to that in 1997?
Provide a succinct answer. 0.98. What is the ratio of the CO2 emissions (% of total fuel combustion) of Tajikistan in 1996 to that in 1997?
Offer a very short reply. 1.13. What is the ratio of the CO2 emissions (% of total fuel combustion) in Arab World in 1996 to that in 1998?
Give a very brief answer. 1. What is the ratio of the CO2 emissions (% of total fuel combustion) of Angola in 1996 to that in 1998?
Provide a succinct answer. 1.13. What is the ratio of the CO2 emissions (% of total fuel combustion) of Greece in 1996 to that in 1998?
Ensure brevity in your answer.  0.94. What is the ratio of the CO2 emissions (% of total fuel combustion) of Tajikistan in 1996 to that in 1998?
Your response must be concise. 1.59. What is the ratio of the CO2 emissions (% of total fuel combustion) of Arab World in 1997 to that in 1998?
Your response must be concise. 0.98. What is the ratio of the CO2 emissions (% of total fuel combustion) in Angola in 1997 to that in 1998?
Offer a very short reply. 1.16. What is the ratio of the CO2 emissions (% of total fuel combustion) of Greece in 1997 to that in 1998?
Ensure brevity in your answer.  0.96. What is the ratio of the CO2 emissions (% of total fuel combustion) of Tajikistan in 1997 to that in 1998?
Your response must be concise. 1.41. What is the difference between the highest and the second highest CO2 emissions (% of total fuel combustion) of Arab World?
Your response must be concise. 0.34. What is the difference between the highest and the second highest CO2 emissions (% of total fuel combustion) of Angola?
Your answer should be compact. 8.11. What is the difference between the highest and the second highest CO2 emissions (% of total fuel combustion) of Greece?
Keep it short and to the point. 0.96. What is the difference between the highest and the second highest CO2 emissions (% of total fuel combustion) in Tajikistan?
Your answer should be compact. 0.85. What is the difference between the highest and the lowest CO2 emissions (% of total fuel combustion) of Arab World?
Ensure brevity in your answer.  2.25. What is the difference between the highest and the lowest CO2 emissions (% of total fuel combustion) in Angola?
Your answer should be very brief. 15.54. What is the difference between the highest and the lowest CO2 emissions (% of total fuel combustion) in Greece?
Provide a succinct answer. 2.05. What is the difference between the highest and the lowest CO2 emissions (% of total fuel combustion) of Tajikistan?
Make the answer very short. 3.38. 